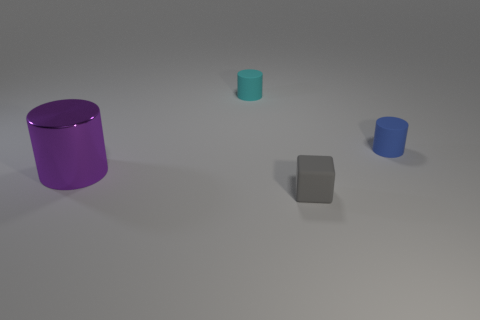Are any small matte cubes visible?
Keep it short and to the point. Yes. The blue cylinder that is made of the same material as the tiny block is what size?
Give a very brief answer. Small. What shape is the object that is to the right of the thing that is in front of the cylinder in front of the blue matte thing?
Your response must be concise. Cylinder. Are there an equal number of purple metal things that are right of the tiny blue rubber thing and purple metal objects?
Keep it short and to the point. No. Is the shape of the large thing the same as the blue matte thing?
Offer a terse response. Yes. What number of things are either cylinders that are on the right side of the large purple cylinder or tiny green metal cylinders?
Your answer should be very brief. 2. Are there an equal number of tiny cyan cylinders on the left side of the tiny cyan cylinder and blocks that are left of the purple shiny cylinder?
Provide a short and direct response. Yes. How many other objects are the same shape as the big metal object?
Offer a very short reply. 2. There is a matte cylinder right of the cube; is it the same size as the thing that is to the left of the cyan object?
Provide a short and direct response. No. How many spheres are shiny things or small gray rubber things?
Your answer should be very brief. 0. 